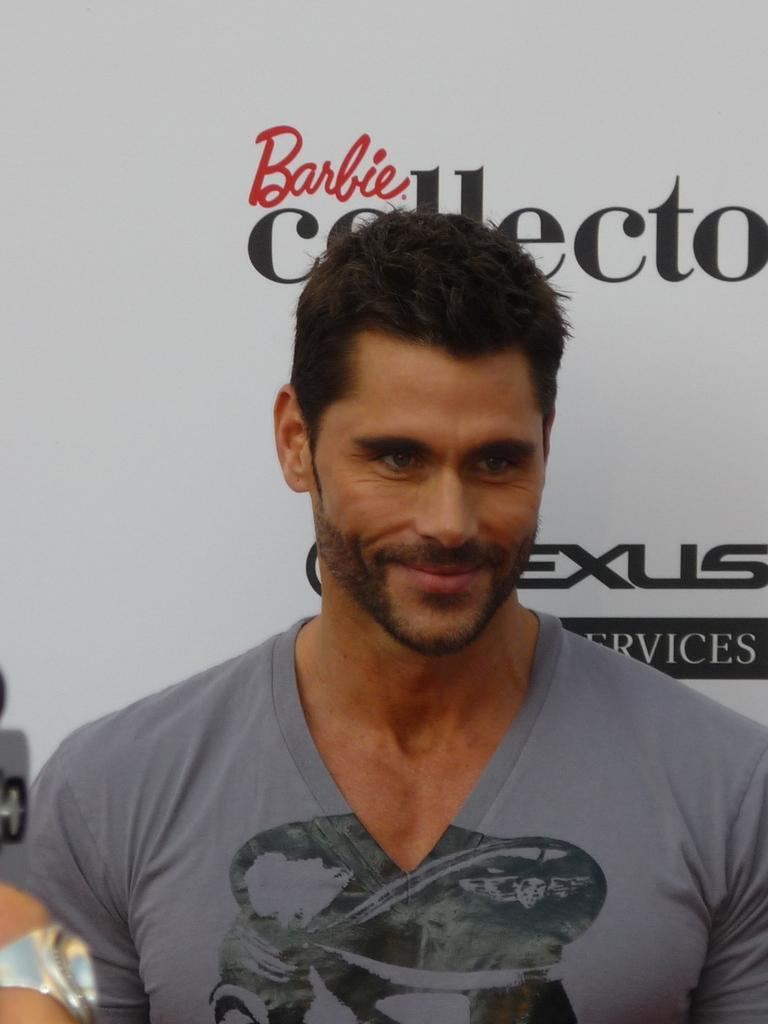Who is present in the image? There is a man in the image. What is the man wearing? The man is wearing a gray T-shirt. What is the man's facial expression? The man is smiling. What can be seen in the background of the image? There is a white banner with an advertisement in the background. What letter does the earth send to the man in the image? There is no letter or reference to the earth in the image; it features a man wearing a gray T-shirt, smiling, and standing in front of a white banner with an advertisement. 